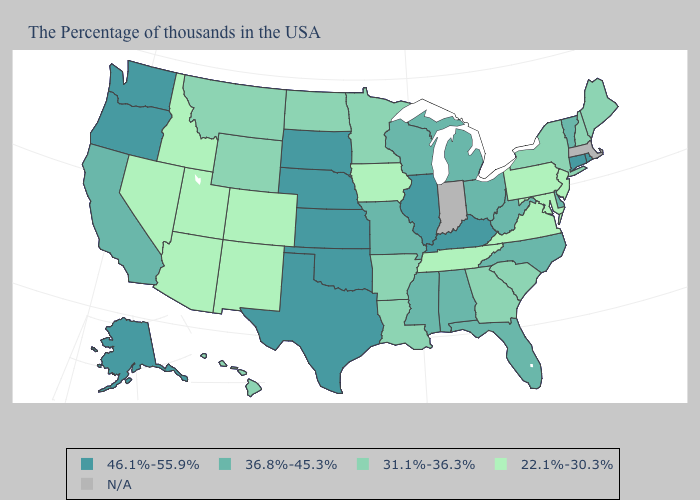What is the value of South Carolina?
Be succinct. 31.1%-36.3%. Name the states that have a value in the range 31.1%-36.3%?
Keep it brief. Maine, New Hampshire, New York, South Carolina, Georgia, Louisiana, Arkansas, Minnesota, North Dakota, Wyoming, Montana, Hawaii. Is the legend a continuous bar?
Concise answer only. No. Name the states that have a value in the range 46.1%-55.9%?
Answer briefly. Rhode Island, Connecticut, Kentucky, Illinois, Kansas, Nebraska, Oklahoma, Texas, South Dakota, Washington, Oregon, Alaska. Name the states that have a value in the range 46.1%-55.9%?
Keep it brief. Rhode Island, Connecticut, Kentucky, Illinois, Kansas, Nebraska, Oklahoma, Texas, South Dakota, Washington, Oregon, Alaska. Which states have the lowest value in the MidWest?
Keep it brief. Iowa. Which states have the lowest value in the Northeast?
Concise answer only. New Jersey, Pennsylvania. What is the highest value in states that border Nevada?
Be succinct. 46.1%-55.9%. Name the states that have a value in the range 31.1%-36.3%?
Answer briefly. Maine, New Hampshire, New York, South Carolina, Georgia, Louisiana, Arkansas, Minnesota, North Dakota, Wyoming, Montana, Hawaii. What is the lowest value in the West?
Be succinct. 22.1%-30.3%. What is the value of Minnesota?
Be succinct. 31.1%-36.3%. What is the value of Wisconsin?
Keep it brief. 36.8%-45.3%. Name the states that have a value in the range 22.1%-30.3%?
Answer briefly. New Jersey, Maryland, Pennsylvania, Virginia, Tennessee, Iowa, Colorado, New Mexico, Utah, Arizona, Idaho, Nevada. What is the highest value in the MidWest ?
Concise answer only. 46.1%-55.9%. 